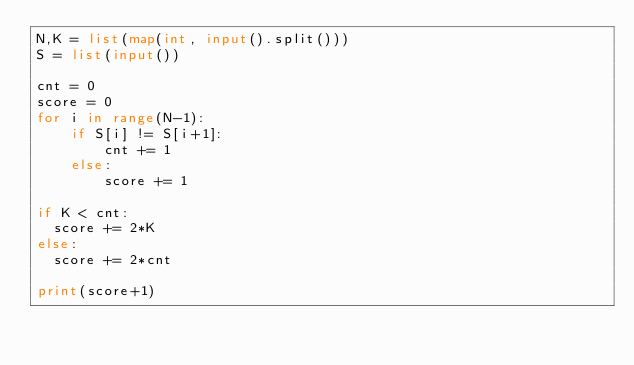Convert code to text. <code><loc_0><loc_0><loc_500><loc_500><_Python_>N,K = list(map(int, input().split()))
S = list(input())

cnt = 0
score = 0
for i in range(N-1):
    if S[i] != S[i+1]:
        cnt += 1
    else:
        score += 1

if K < cnt:
  score += 2*K
else:
  score += 2*cnt

print(score+1)</code> 